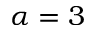<formula> <loc_0><loc_0><loc_500><loc_500>\alpha = 3</formula> 